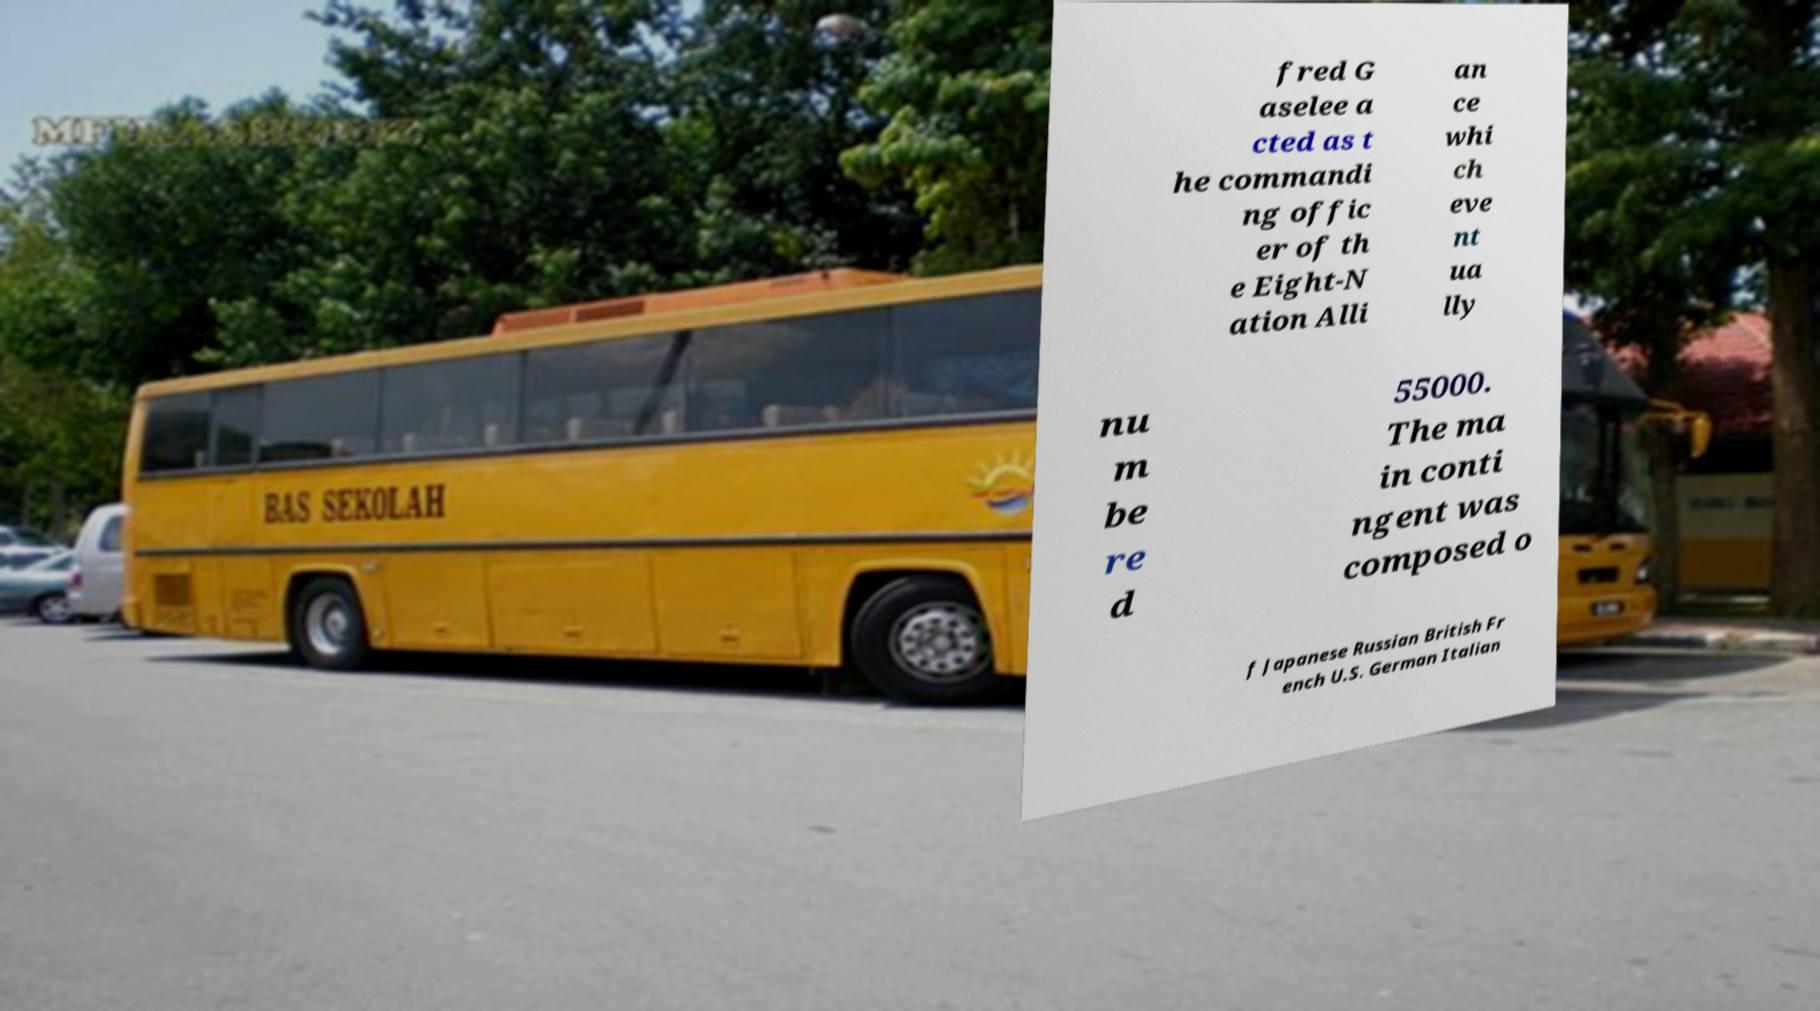Can you read and provide the text displayed in the image?This photo seems to have some interesting text. Can you extract and type it out for me? fred G aselee a cted as t he commandi ng offic er of th e Eight-N ation Alli an ce whi ch eve nt ua lly nu m be re d 55000. The ma in conti ngent was composed o f Japanese Russian British Fr ench U.S. German Italian 